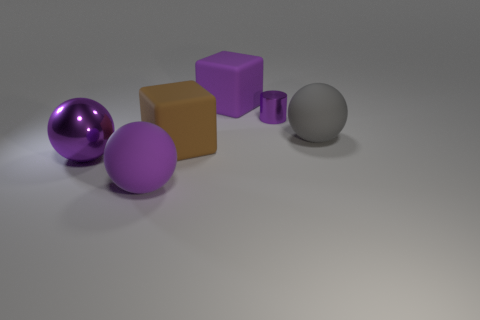Are there any other things that are the same shape as the tiny purple metallic object?
Provide a succinct answer. No. There is a shiny object to the right of the large purple rubber thing behind the big rubber sphere that is left of the small purple thing; what color is it?
Ensure brevity in your answer.  Purple. There is a block that is behind the purple cylinder; are there any small purple objects in front of it?
Offer a very short reply. Yes. Is the color of the metallic object that is in front of the purple metallic cylinder the same as the matte object that is behind the gray rubber object?
Keep it short and to the point. Yes. How many purple rubber balls have the same size as the gray matte object?
Give a very brief answer. 1. Does the purple rubber object behind the purple metallic cylinder have the same size as the big metallic thing?
Keep it short and to the point. Yes. The large purple metal object is what shape?
Your response must be concise. Sphere. What size is the metal object that is the same color as the metal sphere?
Make the answer very short. Small. Are the big cube that is in front of the big purple cube and the purple cube made of the same material?
Offer a terse response. Yes. Is there a large ball that has the same color as the tiny metallic cylinder?
Provide a short and direct response. Yes. 